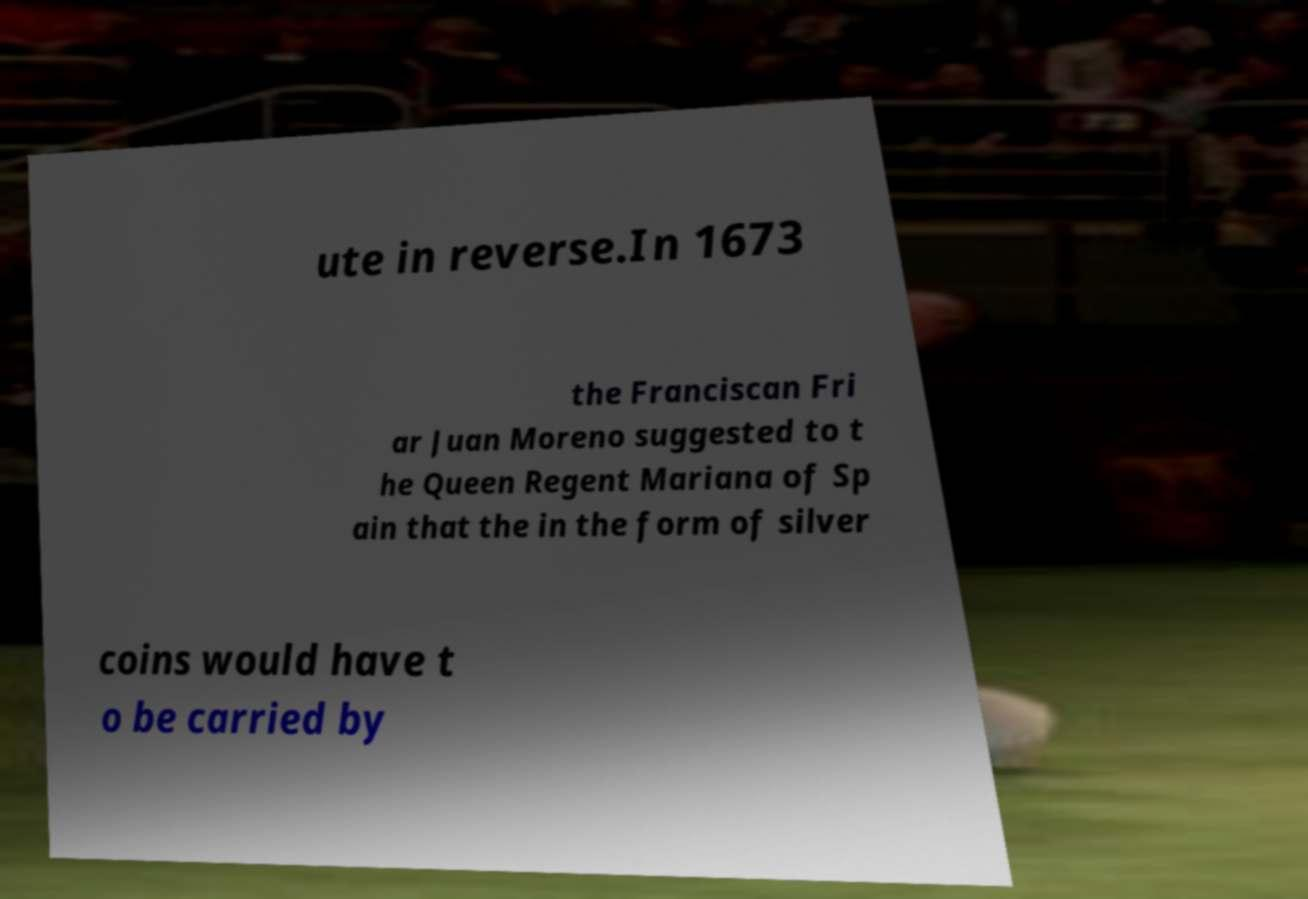Could you extract and type out the text from this image? ute in reverse.In 1673 the Franciscan Fri ar Juan Moreno suggested to t he Queen Regent Mariana of Sp ain that the in the form of silver coins would have t o be carried by 